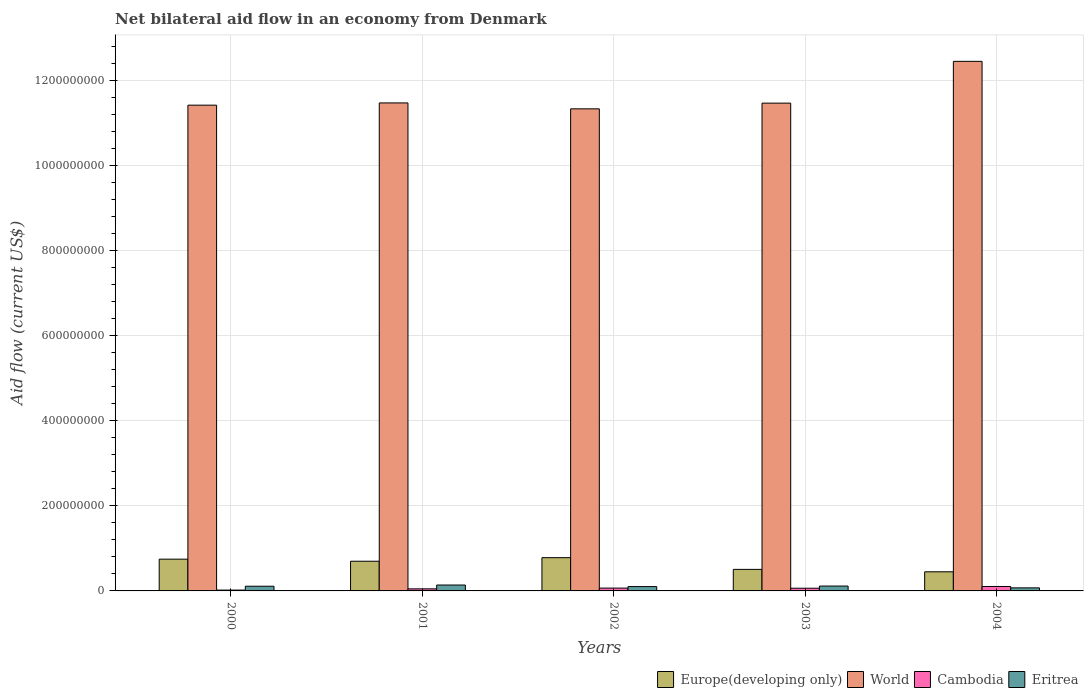How many different coloured bars are there?
Ensure brevity in your answer.  4. Are the number of bars per tick equal to the number of legend labels?
Your response must be concise. Yes. How many bars are there on the 3rd tick from the right?
Ensure brevity in your answer.  4. What is the label of the 2nd group of bars from the left?
Keep it short and to the point. 2001. What is the net bilateral aid flow in Europe(developing only) in 2002?
Ensure brevity in your answer.  7.82e+07. Across all years, what is the maximum net bilateral aid flow in World?
Your answer should be compact. 1.25e+09. Across all years, what is the minimum net bilateral aid flow in Europe(developing only)?
Offer a very short reply. 4.50e+07. In which year was the net bilateral aid flow in Eritrea minimum?
Offer a terse response. 2004. What is the total net bilateral aid flow in Cambodia in the graph?
Offer a terse response. 3.03e+07. What is the difference between the net bilateral aid flow in Europe(developing only) in 2001 and that in 2002?
Offer a very short reply. -8.35e+06. What is the difference between the net bilateral aid flow in Europe(developing only) in 2000 and the net bilateral aid flow in World in 2001?
Your answer should be compact. -1.07e+09. What is the average net bilateral aid flow in World per year?
Provide a succinct answer. 1.16e+09. In the year 2004, what is the difference between the net bilateral aid flow in World and net bilateral aid flow in Cambodia?
Provide a short and direct response. 1.23e+09. What is the ratio of the net bilateral aid flow in World in 2001 to that in 2002?
Offer a terse response. 1.01. What is the difference between the highest and the second highest net bilateral aid flow in Eritrea?
Offer a terse response. 2.39e+06. What is the difference between the highest and the lowest net bilateral aid flow in World?
Make the answer very short. 1.12e+08. Is the sum of the net bilateral aid flow in Eritrea in 2002 and 2003 greater than the maximum net bilateral aid flow in World across all years?
Your answer should be very brief. No. Is it the case that in every year, the sum of the net bilateral aid flow in Cambodia and net bilateral aid flow in Europe(developing only) is greater than the sum of net bilateral aid flow in Eritrea and net bilateral aid flow in World?
Your answer should be compact. Yes. What does the 3rd bar from the right in 2003 represents?
Your response must be concise. World. How many bars are there?
Your answer should be compact. 20. How many years are there in the graph?
Your answer should be compact. 5. Does the graph contain any zero values?
Your answer should be compact. No. Does the graph contain grids?
Provide a succinct answer. Yes. Where does the legend appear in the graph?
Keep it short and to the point. Bottom right. How many legend labels are there?
Keep it short and to the point. 4. What is the title of the graph?
Offer a terse response. Net bilateral aid flow in an economy from Denmark. What is the label or title of the X-axis?
Provide a succinct answer. Years. What is the Aid flow (current US$) of Europe(developing only) in 2000?
Give a very brief answer. 7.47e+07. What is the Aid flow (current US$) in World in 2000?
Keep it short and to the point. 1.14e+09. What is the Aid flow (current US$) of Cambodia in 2000?
Provide a succinct answer. 1.97e+06. What is the Aid flow (current US$) in Eritrea in 2000?
Offer a very short reply. 1.10e+07. What is the Aid flow (current US$) of Europe(developing only) in 2001?
Your answer should be very brief. 6.98e+07. What is the Aid flow (current US$) in World in 2001?
Your response must be concise. 1.15e+09. What is the Aid flow (current US$) of Cambodia in 2001?
Ensure brevity in your answer.  4.87e+06. What is the Aid flow (current US$) in Eritrea in 2001?
Your answer should be very brief. 1.38e+07. What is the Aid flow (current US$) in Europe(developing only) in 2002?
Give a very brief answer. 7.82e+07. What is the Aid flow (current US$) of World in 2002?
Your response must be concise. 1.13e+09. What is the Aid flow (current US$) of Cambodia in 2002?
Give a very brief answer. 6.64e+06. What is the Aid flow (current US$) in Eritrea in 2002?
Offer a very short reply. 1.02e+07. What is the Aid flow (current US$) of Europe(developing only) in 2003?
Your response must be concise. 5.06e+07. What is the Aid flow (current US$) in World in 2003?
Provide a short and direct response. 1.15e+09. What is the Aid flow (current US$) of Cambodia in 2003?
Provide a short and direct response. 6.33e+06. What is the Aid flow (current US$) of Eritrea in 2003?
Keep it short and to the point. 1.15e+07. What is the Aid flow (current US$) in Europe(developing only) in 2004?
Give a very brief answer. 4.50e+07. What is the Aid flow (current US$) in World in 2004?
Provide a short and direct response. 1.25e+09. What is the Aid flow (current US$) in Cambodia in 2004?
Make the answer very short. 1.05e+07. What is the Aid flow (current US$) in Eritrea in 2004?
Your response must be concise. 7.17e+06. Across all years, what is the maximum Aid flow (current US$) of Europe(developing only)?
Provide a succinct answer. 7.82e+07. Across all years, what is the maximum Aid flow (current US$) in World?
Make the answer very short. 1.25e+09. Across all years, what is the maximum Aid flow (current US$) of Cambodia?
Keep it short and to the point. 1.05e+07. Across all years, what is the maximum Aid flow (current US$) in Eritrea?
Keep it short and to the point. 1.38e+07. Across all years, what is the minimum Aid flow (current US$) of Europe(developing only)?
Your answer should be very brief. 4.50e+07. Across all years, what is the minimum Aid flow (current US$) of World?
Provide a short and direct response. 1.13e+09. Across all years, what is the minimum Aid flow (current US$) of Cambodia?
Your response must be concise. 1.97e+06. Across all years, what is the minimum Aid flow (current US$) in Eritrea?
Offer a very short reply. 7.17e+06. What is the total Aid flow (current US$) of Europe(developing only) in the graph?
Your answer should be very brief. 3.18e+08. What is the total Aid flow (current US$) in World in the graph?
Your answer should be very brief. 5.81e+09. What is the total Aid flow (current US$) of Cambodia in the graph?
Offer a very short reply. 3.03e+07. What is the total Aid flow (current US$) in Eritrea in the graph?
Offer a terse response. 5.37e+07. What is the difference between the Aid flow (current US$) in Europe(developing only) in 2000 and that in 2001?
Make the answer very short. 4.83e+06. What is the difference between the Aid flow (current US$) in World in 2000 and that in 2001?
Keep it short and to the point. -5.28e+06. What is the difference between the Aid flow (current US$) of Cambodia in 2000 and that in 2001?
Provide a short and direct response. -2.90e+06. What is the difference between the Aid flow (current US$) of Eritrea in 2000 and that in 2001?
Your answer should be compact. -2.82e+06. What is the difference between the Aid flow (current US$) in Europe(developing only) in 2000 and that in 2002?
Your response must be concise. -3.52e+06. What is the difference between the Aid flow (current US$) of World in 2000 and that in 2002?
Ensure brevity in your answer.  8.63e+06. What is the difference between the Aid flow (current US$) in Cambodia in 2000 and that in 2002?
Your answer should be very brief. -4.67e+06. What is the difference between the Aid flow (current US$) of Eritrea in 2000 and that in 2002?
Give a very brief answer. 8.50e+05. What is the difference between the Aid flow (current US$) in Europe(developing only) in 2000 and that in 2003?
Provide a succinct answer. 2.40e+07. What is the difference between the Aid flow (current US$) of World in 2000 and that in 2003?
Offer a very short reply. -4.77e+06. What is the difference between the Aid flow (current US$) of Cambodia in 2000 and that in 2003?
Your response must be concise. -4.36e+06. What is the difference between the Aid flow (current US$) of Eritrea in 2000 and that in 2003?
Offer a terse response. -4.30e+05. What is the difference between the Aid flow (current US$) of Europe(developing only) in 2000 and that in 2004?
Your response must be concise. 2.97e+07. What is the difference between the Aid flow (current US$) in World in 2000 and that in 2004?
Keep it short and to the point. -1.03e+08. What is the difference between the Aid flow (current US$) in Cambodia in 2000 and that in 2004?
Your answer should be compact. -8.49e+06. What is the difference between the Aid flow (current US$) of Eritrea in 2000 and that in 2004?
Offer a very short reply. 3.86e+06. What is the difference between the Aid flow (current US$) in Europe(developing only) in 2001 and that in 2002?
Ensure brevity in your answer.  -8.35e+06. What is the difference between the Aid flow (current US$) of World in 2001 and that in 2002?
Your response must be concise. 1.39e+07. What is the difference between the Aid flow (current US$) in Cambodia in 2001 and that in 2002?
Your answer should be very brief. -1.77e+06. What is the difference between the Aid flow (current US$) in Eritrea in 2001 and that in 2002?
Provide a short and direct response. 3.67e+06. What is the difference between the Aid flow (current US$) of Europe(developing only) in 2001 and that in 2003?
Your answer should be compact. 1.92e+07. What is the difference between the Aid flow (current US$) in World in 2001 and that in 2003?
Keep it short and to the point. 5.10e+05. What is the difference between the Aid flow (current US$) in Cambodia in 2001 and that in 2003?
Provide a short and direct response. -1.46e+06. What is the difference between the Aid flow (current US$) of Eritrea in 2001 and that in 2003?
Make the answer very short. 2.39e+06. What is the difference between the Aid flow (current US$) of Europe(developing only) in 2001 and that in 2004?
Your response must be concise. 2.49e+07. What is the difference between the Aid flow (current US$) of World in 2001 and that in 2004?
Your answer should be compact. -9.77e+07. What is the difference between the Aid flow (current US$) in Cambodia in 2001 and that in 2004?
Provide a short and direct response. -5.59e+06. What is the difference between the Aid flow (current US$) in Eritrea in 2001 and that in 2004?
Keep it short and to the point. 6.68e+06. What is the difference between the Aid flow (current US$) in Europe(developing only) in 2002 and that in 2003?
Your answer should be very brief. 2.76e+07. What is the difference between the Aid flow (current US$) in World in 2002 and that in 2003?
Offer a terse response. -1.34e+07. What is the difference between the Aid flow (current US$) of Eritrea in 2002 and that in 2003?
Keep it short and to the point. -1.28e+06. What is the difference between the Aid flow (current US$) of Europe(developing only) in 2002 and that in 2004?
Offer a very short reply. 3.32e+07. What is the difference between the Aid flow (current US$) of World in 2002 and that in 2004?
Keep it short and to the point. -1.12e+08. What is the difference between the Aid flow (current US$) of Cambodia in 2002 and that in 2004?
Keep it short and to the point. -3.82e+06. What is the difference between the Aid flow (current US$) in Eritrea in 2002 and that in 2004?
Keep it short and to the point. 3.01e+06. What is the difference between the Aid flow (current US$) in Europe(developing only) in 2003 and that in 2004?
Provide a succinct answer. 5.67e+06. What is the difference between the Aid flow (current US$) of World in 2003 and that in 2004?
Give a very brief answer. -9.82e+07. What is the difference between the Aid flow (current US$) in Cambodia in 2003 and that in 2004?
Provide a short and direct response. -4.13e+06. What is the difference between the Aid flow (current US$) in Eritrea in 2003 and that in 2004?
Your response must be concise. 4.29e+06. What is the difference between the Aid flow (current US$) of Europe(developing only) in 2000 and the Aid flow (current US$) of World in 2001?
Offer a terse response. -1.07e+09. What is the difference between the Aid flow (current US$) in Europe(developing only) in 2000 and the Aid flow (current US$) in Cambodia in 2001?
Your answer should be compact. 6.98e+07. What is the difference between the Aid flow (current US$) in Europe(developing only) in 2000 and the Aid flow (current US$) in Eritrea in 2001?
Offer a very short reply. 6.08e+07. What is the difference between the Aid flow (current US$) in World in 2000 and the Aid flow (current US$) in Cambodia in 2001?
Give a very brief answer. 1.14e+09. What is the difference between the Aid flow (current US$) of World in 2000 and the Aid flow (current US$) of Eritrea in 2001?
Offer a terse response. 1.13e+09. What is the difference between the Aid flow (current US$) in Cambodia in 2000 and the Aid flow (current US$) in Eritrea in 2001?
Provide a short and direct response. -1.19e+07. What is the difference between the Aid flow (current US$) in Europe(developing only) in 2000 and the Aid flow (current US$) in World in 2002?
Ensure brevity in your answer.  -1.06e+09. What is the difference between the Aid flow (current US$) of Europe(developing only) in 2000 and the Aid flow (current US$) of Cambodia in 2002?
Your answer should be compact. 6.80e+07. What is the difference between the Aid flow (current US$) in Europe(developing only) in 2000 and the Aid flow (current US$) in Eritrea in 2002?
Provide a succinct answer. 6.45e+07. What is the difference between the Aid flow (current US$) in World in 2000 and the Aid flow (current US$) in Cambodia in 2002?
Your answer should be very brief. 1.14e+09. What is the difference between the Aid flow (current US$) of World in 2000 and the Aid flow (current US$) of Eritrea in 2002?
Your response must be concise. 1.13e+09. What is the difference between the Aid flow (current US$) in Cambodia in 2000 and the Aid flow (current US$) in Eritrea in 2002?
Provide a short and direct response. -8.21e+06. What is the difference between the Aid flow (current US$) of Europe(developing only) in 2000 and the Aid flow (current US$) of World in 2003?
Your response must be concise. -1.07e+09. What is the difference between the Aid flow (current US$) in Europe(developing only) in 2000 and the Aid flow (current US$) in Cambodia in 2003?
Your answer should be very brief. 6.83e+07. What is the difference between the Aid flow (current US$) in Europe(developing only) in 2000 and the Aid flow (current US$) in Eritrea in 2003?
Provide a succinct answer. 6.32e+07. What is the difference between the Aid flow (current US$) in World in 2000 and the Aid flow (current US$) in Cambodia in 2003?
Your response must be concise. 1.14e+09. What is the difference between the Aid flow (current US$) in World in 2000 and the Aid flow (current US$) in Eritrea in 2003?
Your response must be concise. 1.13e+09. What is the difference between the Aid flow (current US$) in Cambodia in 2000 and the Aid flow (current US$) in Eritrea in 2003?
Give a very brief answer. -9.49e+06. What is the difference between the Aid flow (current US$) in Europe(developing only) in 2000 and the Aid flow (current US$) in World in 2004?
Provide a succinct answer. -1.17e+09. What is the difference between the Aid flow (current US$) of Europe(developing only) in 2000 and the Aid flow (current US$) of Cambodia in 2004?
Keep it short and to the point. 6.42e+07. What is the difference between the Aid flow (current US$) in Europe(developing only) in 2000 and the Aid flow (current US$) in Eritrea in 2004?
Keep it short and to the point. 6.75e+07. What is the difference between the Aid flow (current US$) of World in 2000 and the Aid flow (current US$) of Cambodia in 2004?
Ensure brevity in your answer.  1.13e+09. What is the difference between the Aid flow (current US$) in World in 2000 and the Aid flow (current US$) in Eritrea in 2004?
Give a very brief answer. 1.13e+09. What is the difference between the Aid flow (current US$) in Cambodia in 2000 and the Aid flow (current US$) in Eritrea in 2004?
Your answer should be very brief. -5.20e+06. What is the difference between the Aid flow (current US$) of Europe(developing only) in 2001 and the Aid flow (current US$) of World in 2002?
Keep it short and to the point. -1.06e+09. What is the difference between the Aid flow (current US$) of Europe(developing only) in 2001 and the Aid flow (current US$) of Cambodia in 2002?
Provide a succinct answer. 6.32e+07. What is the difference between the Aid flow (current US$) in Europe(developing only) in 2001 and the Aid flow (current US$) in Eritrea in 2002?
Offer a very short reply. 5.96e+07. What is the difference between the Aid flow (current US$) of World in 2001 and the Aid flow (current US$) of Cambodia in 2002?
Make the answer very short. 1.14e+09. What is the difference between the Aid flow (current US$) in World in 2001 and the Aid flow (current US$) in Eritrea in 2002?
Your response must be concise. 1.14e+09. What is the difference between the Aid flow (current US$) in Cambodia in 2001 and the Aid flow (current US$) in Eritrea in 2002?
Offer a very short reply. -5.31e+06. What is the difference between the Aid flow (current US$) in Europe(developing only) in 2001 and the Aid flow (current US$) in World in 2003?
Provide a succinct answer. -1.08e+09. What is the difference between the Aid flow (current US$) in Europe(developing only) in 2001 and the Aid flow (current US$) in Cambodia in 2003?
Offer a very short reply. 6.35e+07. What is the difference between the Aid flow (current US$) of Europe(developing only) in 2001 and the Aid flow (current US$) of Eritrea in 2003?
Offer a very short reply. 5.84e+07. What is the difference between the Aid flow (current US$) in World in 2001 and the Aid flow (current US$) in Cambodia in 2003?
Provide a succinct answer. 1.14e+09. What is the difference between the Aid flow (current US$) in World in 2001 and the Aid flow (current US$) in Eritrea in 2003?
Offer a terse response. 1.14e+09. What is the difference between the Aid flow (current US$) in Cambodia in 2001 and the Aid flow (current US$) in Eritrea in 2003?
Ensure brevity in your answer.  -6.59e+06. What is the difference between the Aid flow (current US$) in Europe(developing only) in 2001 and the Aid flow (current US$) in World in 2004?
Provide a short and direct response. -1.18e+09. What is the difference between the Aid flow (current US$) in Europe(developing only) in 2001 and the Aid flow (current US$) in Cambodia in 2004?
Your response must be concise. 5.94e+07. What is the difference between the Aid flow (current US$) of Europe(developing only) in 2001 and the Aid flow (current US$) of Eritrea in 2004?
Keep it short and to the point. 6.27e+07. What is the difference between the Aid flow (current US$) in World in 2001 and the Aid flow (current US$) in Cambodia in 2004?
Keep it short and to the point. 1.14e+09. What is the difference between the Aid flow (current US$) in World in 2001 and the Aid flow (current US$) in Eritrea in 2004?
Provide a short and direct response. 1.14e+09. What is the difference between the Aid flow (current US$) in Cambodia in 2001 and the Aid flow (current US$) in Eritrea in 2004?
Provide a succinct answer. -2.30e+06. What is the difference between the Aid flow (current US$) of Europe(developing only) in 2002 and the Aid flow (current US$) of World in 2003?
Your response must be concise. -1.07e+09. What is the difference between the Aid flow (current US$) in Europe(developing only) in 2002 and the Aid flow (current US$) in Cambodia in 2003?
Provide a short and direct response. 7.18e+07. What is the difference between the Aid flow (current US$) of Europe(developing only) in 2002 and the Aid flow (current US$) of Eritrea in 2003?
Keep it short and to the point. 6.67e+07. What is the difference between the Aid flow (current US$) in World in 2002 and the Aid flow (current US$) in Cambodia in 2003?
Give a very brief answer. 1.13e+09. What is the difference between the Aid flow (current US$) in World in 2002 and the Aid flow (current US$) in Eritrea in 2003?
Your answer should be very brief. 1.12e+09. What is the difference between the Aid flow (current US$) of Cambodia in 2002 and the Aid flow (current US$) of Eritrea in 2003?
Offer a very short reply. -4.82e+06. What is the difference between the Aid flow (current US$) in Europe(developing only) in 2002 and the Aid flow (current US$) in World in 2004?
Your answer should be very brief. -1.17e+09. What is the difference between the Aid flow (current US$) of Europe(developing only) in 2002 and the Aid flow (current US$) of Cambodia in 2004?
Offer a very short reply. 6.77e+07. What is the difference between the Aid flow (current US$) in Europe(developing only) in 2002 and the Aid flow (current US$) in Eritrea in 2004?
Keep it short and to the point. 7.10e+07. What is the difference between the Aid flow (current US$) of World in 2002 and the Aid flow (current US$) of Cambodia in 2004?
Make the answer very short. 1.12e+09. What is the difference between the Aid flow (current US$) of World in 2002 and the Aid flow (current US$) of Eritrea in 2004?
Give a very brief answer. 1.13e+09. What is the difference between the Aid flow (current US$) in Cambodia in 2002 and the Aid flow (current US$) in Eritrea in 2004?
Ensure brevity in your answer.  -5.30e+05. What is the difference between the Aid flow (current US$) in Europe(developing only) in 2003 and the Aid flow (current US$) in World in 2004?
Provide a short and direct response. -1.19e+09. What is the difference between the Aid flow (current US$) in Europe(developing only) in 2003 and the Aid flow (current US$) in Cambodia in 2004?
Make the answer very short. 4.02e+07. What is the difference between the Aid flow (current US$) in Europe(developing only) in 2003 and the Aid flow (current US$) in Eritrea in 2004?
Offer a terse response. 4.35e+07. What is the difference between the Aid flow (current US$) of World in 2003 and the Aid flow (current US$) of Cambodia in 2004?
Make the answer very short. 1.14e+09. What is the difference between the Aid flow (current US$) in World in 2003 and the Aid flow (current US$) in Eritrea in 2004?
Provide a succinct answer. 1.14e+09. What is the difference between the Aid flow (current US$) of Cambodia in 2003 and the Aid flow (current US$) of Eritrea in 2004?
Ensure brevity in your answer.  -8.40e+05. What is the average Aid flow (current US$) in Europe(developing only) per year?
Offer a very short reply. 6.37e+07. What is the average Aid flow (current US$) of World per year?
Make the answer very short. 1.16e+09. What is the average Aid flow (current US$) of Cambodia per year?
Keep it short and to the point. 6.05e+06. What is the average Aid flow (current US$) of Eritrea per year?
Make the answer very short. 1.07e+07. In the year 2000, what is the difference between the Aid flow (current US$) in Europe(developing only) and Aid flow (current US$) in World?
Give a very brief answer. -1.07e+09. In the year 2000, what is the difference between the Aid flow (current US$) in Europe(developing only) and Aid flow (current US$) in Cambodia?
Provide a succinct answer. 7.27e+07. In the year 2000, what is the difference between the Aid flow (current US$) of Europe(developing only) and Aid flow (current US$) of Eritrea?
Your response must be concise. 6.36e+07. In the year 2000, what is the difference between the Aid flow (current US$) of World and Aid flow (current US$) of Cambodia?
Make the answer very short. 1.14e+09. In the year 2000, what is the difference between the Aid flow (current US$) of World and Aid flow (current US$) of Eritrea?
Your answer should be very brief. 1.13e+09. In the year 2000, what is the difference between the Aid flow (current US$) in Cambodia and Aid flow (current US$) in Eritrea?
Provide a short and direct response. -9.06e+06. In the year 2001, what is the difference between the Aid flow (current US$) in Europe(developing only) and Aid flow (current US$) in World?
Give a very brief answer. -1.08e+09. In the year 2001, what is the difference between the Aid flow (current US$) in Europe(developing only) and Aid flow (current US$) in Cambodia?
Give a very brief answer. 6.50e+07. In the year 2001, what is the difference between the Aid flow (current US$) of Europe(developing only) and Aid flow (current US$) of Eritrea?
Give a very brief answer. 5.60e+07. In the year 2001, what is the difference between the Aid flow (current US$) of World and Aid flow (current US$) of Cambodia?
Your response must be concise. 1.14e+09. In the year 2001, what is the difference between the Aid flow (current US$) in World and Aid flow (current US$) in Eritrea?
Keep it short and to the point. 1.13e+09. In the year 2001, what is the difference between the Aid flow (current US$) in Cambodia and Aid flow (current US$) in Eritrea?
Provide a short and direct response. -8.98e+06. In the year 2002, what is the difference between the Aid flow (current US$) in Europe(developing only) and Aid flow (current US$) in World?
Offer a terse response. -1.06e+09. In the year 2002, what is the difference between the Aid flow (current US$) in Europe(developing only) and Aid flow (current US$) in Cambodia?
Offer a terse response. 7.15e+07. In the year 2002, what is the difference between the Aid flow (current US$) of Europe(developing only) and Aid flow (current US$) of Eritrea?
Make the answer very short. 6.80e+07. In the year 2002, what is the difference between the Aid flow (current US$) in World and Aid flow (current US$) in Cambodia?
Provide a succinct answer. 1.13e+09. In the year 2002, what is the difference between the Aid flow (current US$) in World and Aid flow (current US$) in Eritrea?
Provide a short and direct response. 1.12e+09. In the year 2002, what is the difference between the Aid flow (current US$) in Cambodia and Aid flow (current US$) in Eritrea?
Offer a very short reply. -3.54e+06. In the year 2003, what is the difference between the Aid flow (current US$) of Europe(developing only) and Aid flow (current US$) of World?
Provide a short and direct response. -1.10e+09. In the year 2003, what is the difference between the Aid flow (current US$) of Europe(developing only) and Aid flow (current US$) of Cambodia?
Provide a succinct answer. 4.43e+07. In the year 2003, what is the difference between the Aid flow (current US$) of Europe(developing only) and Aid flow (current US$) of Eritrea?
Make the answer very short. 3.92e+07. In the year 2003, what is the difference between the Aid flow (current US$) in World and Aid flow (current US$) in Cambodia?
Your response must be concise. 1.14e+09. In the year 2003, what is the difference between the Aid flow (current US$) in World and Aid flow (current US$) in Eritrea?
Offer a terse response. 1.14e+09. In the year 2003, what is the difference between the Aid flow (current US$) in Cambodia and Aid flow (current US$) in Eritrea?
Provide a succinct answer. -5.13e+06. In the year 2004, what is the difference between the Aid flow (current US$) of Europe(developing only) and Aid flow (current US$) of World?
Give a very brief answer. -1.20e+09. In the year 2004, what is the difference between the Aid flow (current US$) of Europe(developing only) and Aid flow (current US$) of Cambodia?
Provide a succinct answer. 3.45e+07. In the year 2004, what is the difference between the Aid flow (current US$) of Europe(developing only) and Aid flow (current US$) of Eritrea?
Offer a terse response. 3.78e+07. In the year 2004, what is the difference between the Aid flow (current US$) in World and Aid flow (current US$) in Cambodia?
Offer a terse response. 1.23e+09. In the year 2004, what is the difference between the Aid flow (current US$) of World and Aid flow (current US$) of Eritrea?
Make the answer very short. 1.24e+09. In the year 2004, what is the difference between the Aid flow (current US$) of Cambodia and Aid flow (current US$) of Eritrea?
Provide a succinct answer. 3.29e+06. What is the ratio of the Aid flow (current US$) of Europe(developing only) in 2000 to that in 2001?
Offer a very short reply. 1.07. What is the ratio of the Aid flow (current US$) of World in 2000 to that in 2001?
Provide a succinct answer. 1. What is the ratio of the Aid flow (current US$) of Cambodia in 2000 to that in 2001?
Your answer should be very brief. 0.4. What is the ratio of the Aid flow (current US$) in Eritrea in 2000 to that in 2001?
Your answer should be very brief. 0.8. What is the ratio of the Aid flow (current US$) of Europe(developing only) in 2000 to that in 2002?
Provide a short and direct response. 0.95. What is the ratio of the Aid flow (current US$) in World in 2000 to that in 2002?
Offer a very short reply. 1.01. What is the ratio of the Aid flow (current US$) of Cambodia in 2000 to that in 2002?
Offer a very short reply. 0.3. What is the ratio of the Aid flow (current US$) of Eritrea in 2000 to that in 2002?
Ensure brevity in your answer.  1.08. What is the ratio of the Aid flow (current US$) in Europe(developing only) in 2000 to that in 2003?
Keep it short and to the point. 1.47. What is the ratio of the Aid flow (current US$) of Cambodia in 2000 to that in 2003?
Provide a short and direct response. 0.31. What is the ratio of the Aid flow (current US$) in Eritrea in 2000 to that in 2003?
Make the answer very short. 0.96. What is the ratio of the Aid flow (current US$) in Europe(developing only) in 2000 to that in 2004?
Your answer should be very brief. 1.66. What is the ratio of the Aid flow (current US$) in World in 2000 to that in 2004?
Provide a short and direct response. 0.92. What is the ratio of the Aid flow (current US$) in Cambodia in 2000 to that in 2004?
Give a very brief answer. 0.19. What is the ratio of the Aid flow (current US$) in Eritrea in 2000 to that in 2004?
Make the answer very short. 1.54. What is the ratio of the Aid flow (current US$) in Europe(developing only) in 2001 to that in 2002?
Offer a terse response. 0.89. What is the ratio of the Aid flow (current US$) of World in 2001 to that in 2002?
Provide a succinct answer. 1.01. What is the ratio of the Aid flow (current US$) of Cambodia in 2001 to that in 2002?
Offer a terse response. 0.73. What is the ratio of the Aid flow (current US$) of Eritrea in 2001 to that in 2002?
Give a very brief answer. 1.36. What is the ratio of the Aid flow (current US$) of Europe(developing only) in 2001 to that in 2003?
Provide a short and direct response. 1.38. What is the ratio of the Aid flow (current US$) of World in 2001 to that in 2003?
Provide a succinct answer. 1. What is the ratio of the Aid flow (current US$) of Cambodia in 2001 to that in 2003?
Keep it short and to the point. 0.77. What is the ratio of the Aid flow (current US$) in Eritrea in 2001 to that in 2003?
Offer a very short reply. 1.21. What is the ratio of the Aid flow (current US$) of Europe(developing only) in 2001 to that in 2004?
Your response must be concise. 1.55. What is the ratio of the Aid flow (current US$) of World in 2001 to that in 2004?
Provide a short and direct response. 0.92. What is the ratio of the Aid flow (current US$) in Cambodia in 2001 to that in 2004?
Your response must be concise. 0.47. What is the ratio of the Aid flow (current US$) in Eritrea in 2001 to that in 2004?
Give a very brief answer. 1.93. What is the ratio of the Aid flow (current US$) in Europe(developing only) in 2002 to that in 2003?
Ensure brevity in your answer.  1.54. What is the ratio of the Aid flow (current US$) of World in 2002 to that in 2003?
Ensure brevity in your answer.  0.99. What is the ratio of the Aid flow (current US$) in Cambodia in 2002 to that in 2003?
Offer a terse response. 1.05. What is the ratio of the Aid flow (current US$) of Eritrea in 2002 to that in 2003?
Ensure brevity in your answer.  0.89. What is the ratio of the Aid flow (current US$) of Europe(developing only) in 2002 to that in 2004?
Give a very brief answer. 1.74. What is the ratio of the Aid flow (current US$) in World in 2002 to that in 2004?
Provide a short and direct response. 0.91. What is the ratio of the Aid flow (current US$) in Cambodia in 2002 to that in 2004?
Make the answer very short. 0.63. What is the ratio of the Aid flow (current US$) in Eritrea in 2002 to that in 2004?
Offer a terse response. 1.42. What is the ratio of the Aid flow (current US$) in Europe(developing only) in 2003 to that in 2004?
Your response must be concise. 1.13. What is the ratio of the Aid flow (current US$) of World in 2003 to that in 2004?
Ensure brevity in your answer.  0.92. What is the ratio of the Aid flow (current US$) in Cambodia in 2003 to that in 2004?
Offer a terse response. 0.61. What is the ratio of the Aid flow (current US$) in Eritrea in 2003 to that in 2004?
Your answer should be very brief. 1.6. What is the difference between the highest and the second highest Aid flow (current US$) in Europe(developing only)?
Offer a very short reply. 3.52e+06. What is the difference between the highest and the second highest Aid flow (current US$) in World?
Keep it short and to the point. 9.77e+07. What is the difference between the highest and the second highest Aid flow (current US$) in Cambodia?
Your response must be concise. 3.82e+06. What is the difference between the highest and the second highest Aid flow (current US$) of Eritrea?
Offer a very short reply. 2.39e+06. What is the difference between the highest and the lowest Aid flow (current US$) in Europe(developing only)?
Offer a terse response. 3.32e+07. What is the difference between the highest and the lowest Aid flow (current US$) in World?
Offer a very short reply. 1.12e+08. What is the difference between the highest and the lowest Aid flow (current US$) in Cambodia?
Make the answer very short. 8.49e+06. What is the difference between the highest and the lowest Aid flow (current US$) in Eritrea?
Provide a succinct answer. 6.68e+06. 